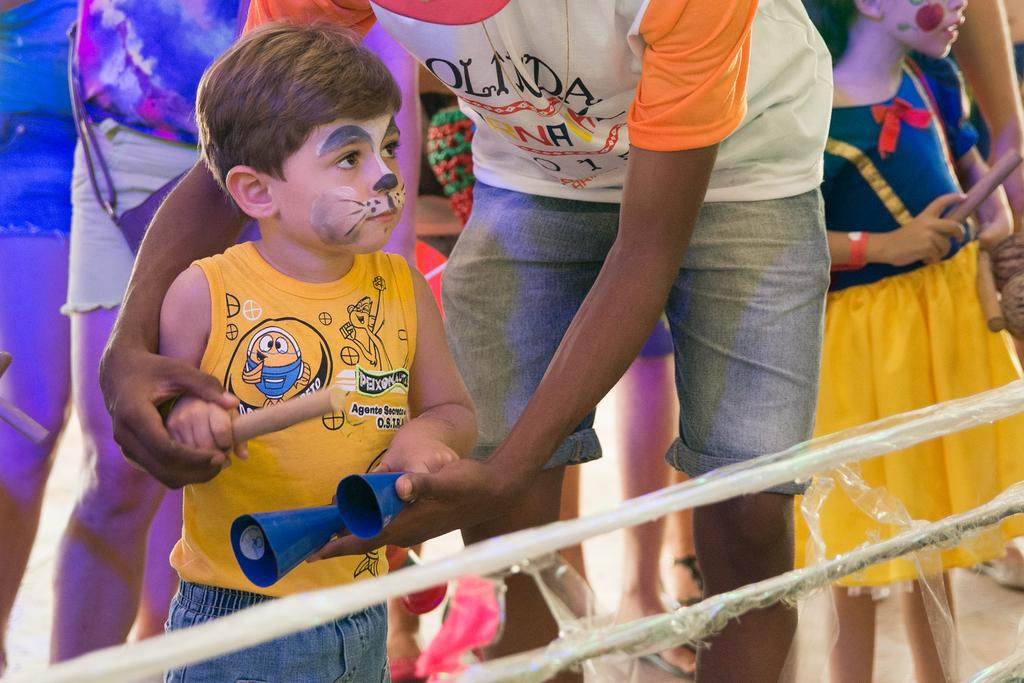How many people are in the image? There are many persons standing in the image. What is the surface on which the persons are standing? The persons are standing on the ground. What can be seen at the bottom of the image? There are iron rods at the bottom of the image. Can you see any snails crawling on the persons in the image? There are no snails visible in the image. What type of body language can be observed between the persons in the image? The provided facts do not give information about the body language or interactions between the persons in the image. 